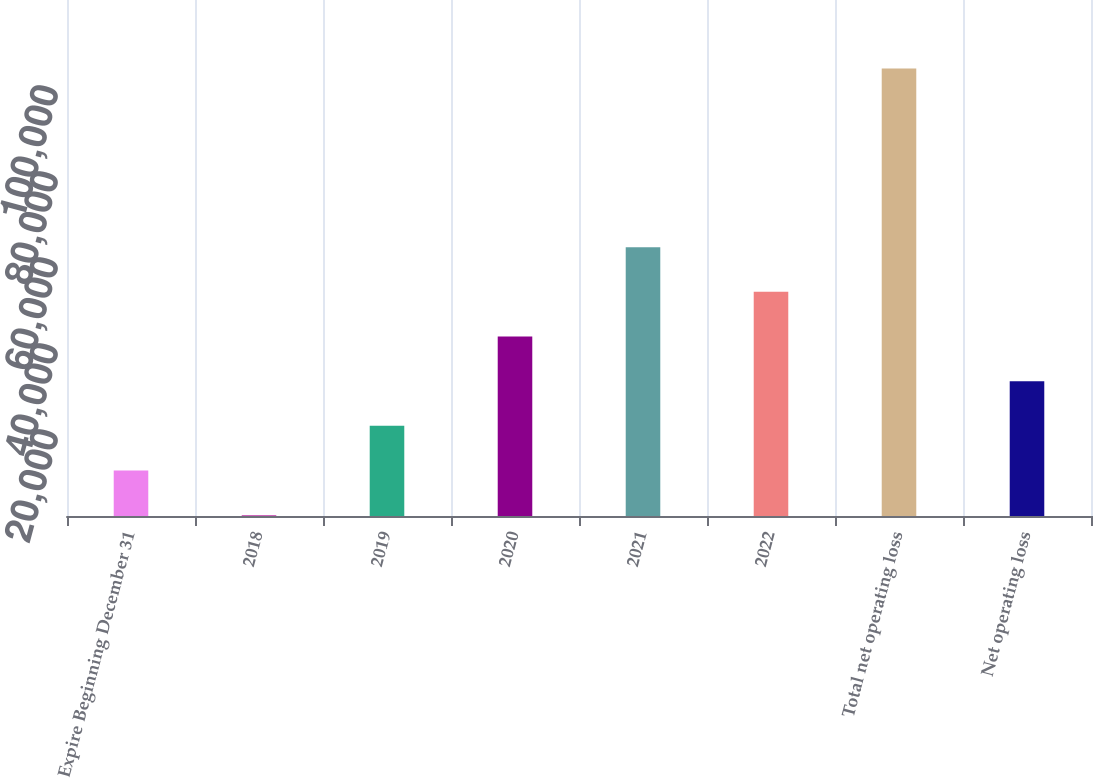<chart> <loc_0><loc_0><loc_500><loc_500><bar_chart><fcel>Expire Beginning December 31<fcel>2018<fcel>2019<fcel>2020<fcel>2021<fcel>2022<fcel>Total net operating loss<fcel>Net operating loss<nl><fcel>10576.2<fcel>189<fcel>20963.4<fcel>41737.8<fcel>62512.2<fcel>52125<fcel>104061<fcel>31350.6<nl></chart> 